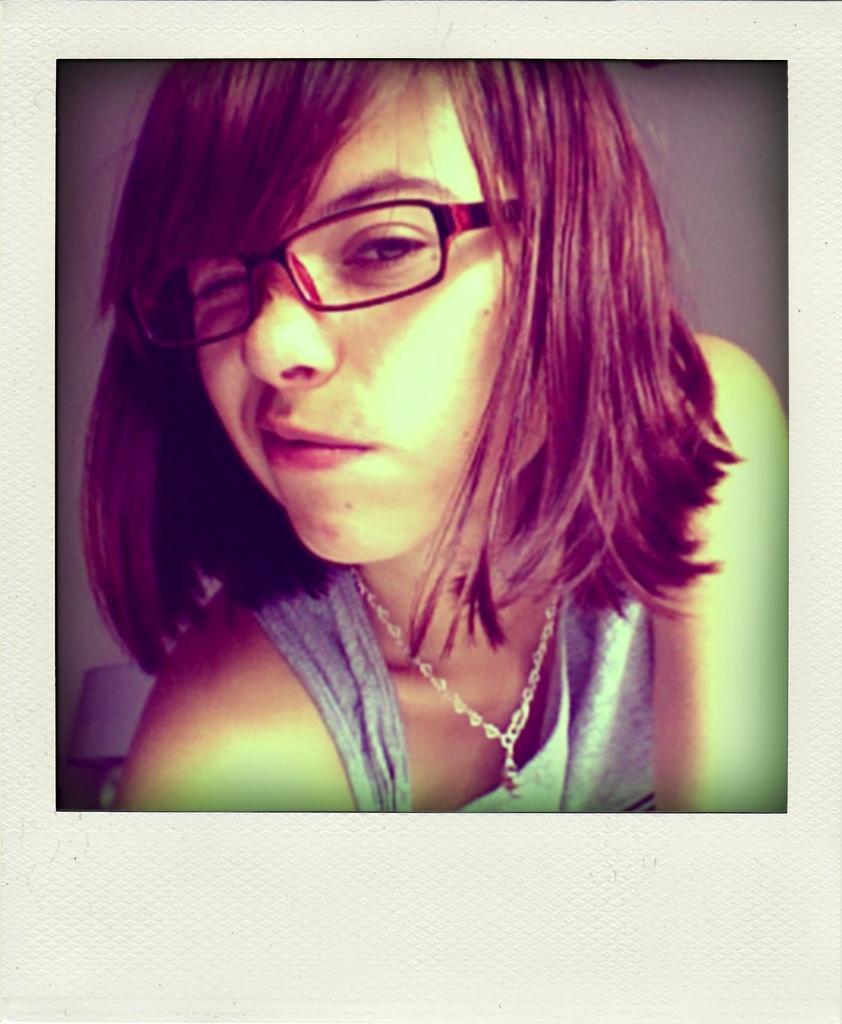How would you summarize this image in a sentence or two? In this image we can see a woman wearing the spectacles and the background, it looks like the wall. 